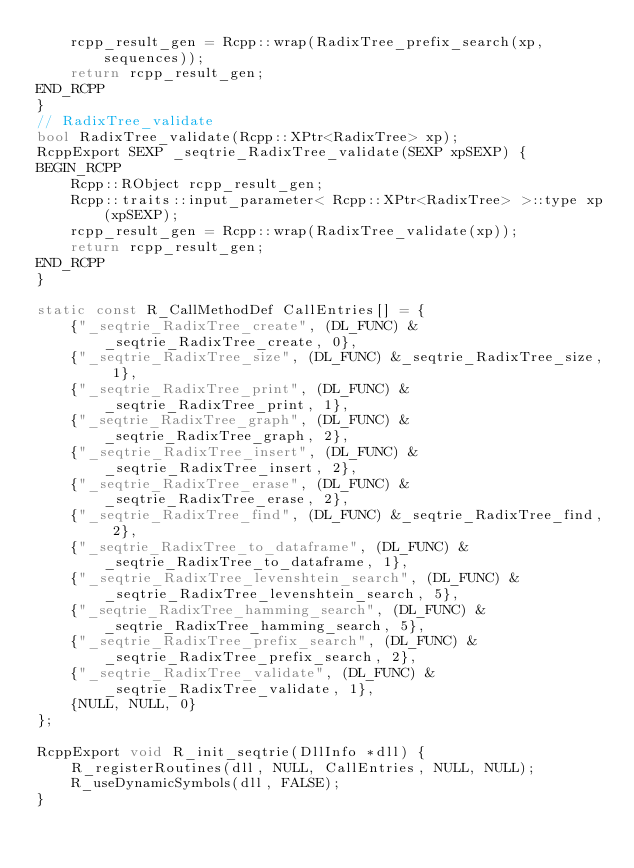Convert code to text. <code><loc_0><loc_0><loc_500><loc_500><_C++_>    rcpp_result_gen = Rcpp::wrap(RadixTree_prefix_search(xp, sequences));
    return rcpp_result_gen;
END_RCPP
}
// RadixTree_validate
bool RadixTree_validate(Rcpp::XPtr<RadixTree> xp);
RcppExport SEXP _seqtrie_RadixTree_validate(SEXP xpSEXP) {
BEGIN_RCPP
    Rcpp::RObject rcpp_result_gen;
    Rcpp::traits::input_parameter< Rcpp::XPtr<RadixTree> >::type xp(xpSEXP);
    rcpp_result_gen = Rcpp::wrap(RadixTree_validate(xp));
    return rcpp_result_gen;
END_RCPP
}

static const R_CallMethodDef CallEntries[] = {
    {"_seqtrie_RadixTree_create", (DL_FUNC) &_seqtrie_RadixTree_create, 0},
    {"_seqtrie_RadixTree_size", (DL_FUNC) &_seqtrie_RadixTree_size, 1},
    {"_seqtrie_RadixTree_print", (DL_FUNC) &_seqtrie_RadixTree_print, 1},
    {"_seqtrie_RadixTree_graph", (DL_FUNC) &_seqtrie_RadixTree_graph, 2},
    {"_seqtrie_RadixTree_insert", (DL_FUNC) &_seqtrie_RadixTree_insert, 2},
    {"_seqtrie_RadixTree_erase", (DL_FUNC) &_seqtrie_RadixTree_erase, 2},
    {"_seqtrie_RadixTree_find", (DL_FUNC) &_seqtrie_RadixTree_find, 2},
    {"_seqtrie_RadixTree_to_dataframe", (DL_FUNC) &_seqtrie_RadixTree_to_dataframe, 1},
    {"_seqtrie_RadixTree_levenshtein_search", (DL_FUNC) &_seqtrie_RadixTree_levenshtein_search, 5},
    {"_seqtrie_RadixTree_hamming_search", (DL_FUNC) &_seqtrie_RadixTree_hamming_search, 5},
    {"_seqtrie_RadixTree_prefix_search", (DL_FUNC) &_seqtrie_RadixTree_prefix_search, 2},
    {"_seqtrie_RadixTree_validate", (DL_FUNC) &_seqtrie_RadixTree_validate, 1},
    {NULL, NULL, 0}
};

RcppExport void R_init_seqtrie(DllInfo *dll) {
    R_registerRoutines(dll, NULL, CallEntries, NULL, NULL);
    R_useDynamicSymbols(dll, FALSE);
}
</code> 